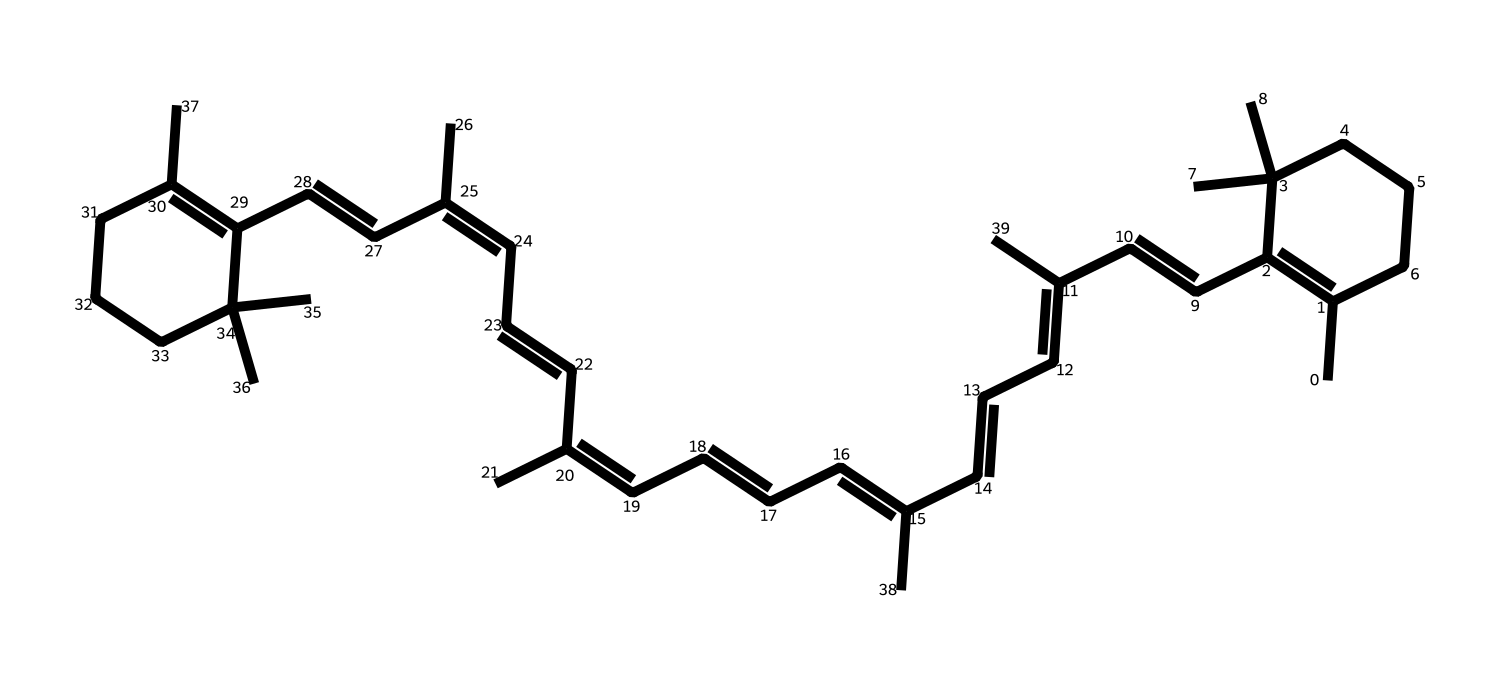What is the empirical formula for beta-carotene? To determine the empirical formula, count the number of each type of atom in the SMILES representation. The SMILES shows multiple carbon (C) atoms and hydrogen (H) atoms, resulting in a formula of C40H56.
Answer: C40H56 How many double bonds are present in the beta-carotene structure? By analyzing the structure derived from the SMILES, count the number of double bonds. Beta-carotene has at least 11 double bonds indicated by the '=' in its structure.
Answer: 11 Is beta-carotene a saturated or unsaturated compound? The presence of double bonds in the chemical structure indicates that beta-carotene is unsaturated, which means it contains at least one double bond.
Answer: unsaturated What type of food coloring is beta-carotene classified as? Beta-carotene is derived naturally from plants, primarily found in carrots and used as a coloring agent, classifying it as a natural food coloring.
Answer: natural Which part of beta-carotene contributes to its color? The conjugated double bonds in the structure absorb specific wavelengths of light, contributing to the compound's orange hue. This part is responsible for its color and reflects the interaction of light with the alternating double bonds.
Answer: conjugated double bonds What is the primary source of beta-carotene in food? Common natural sources include carrots, sweet potatoes, and spinach, which are rich in beta-carotene, providing vibrant color as well as nutritional benefits.
Answer: carrots 